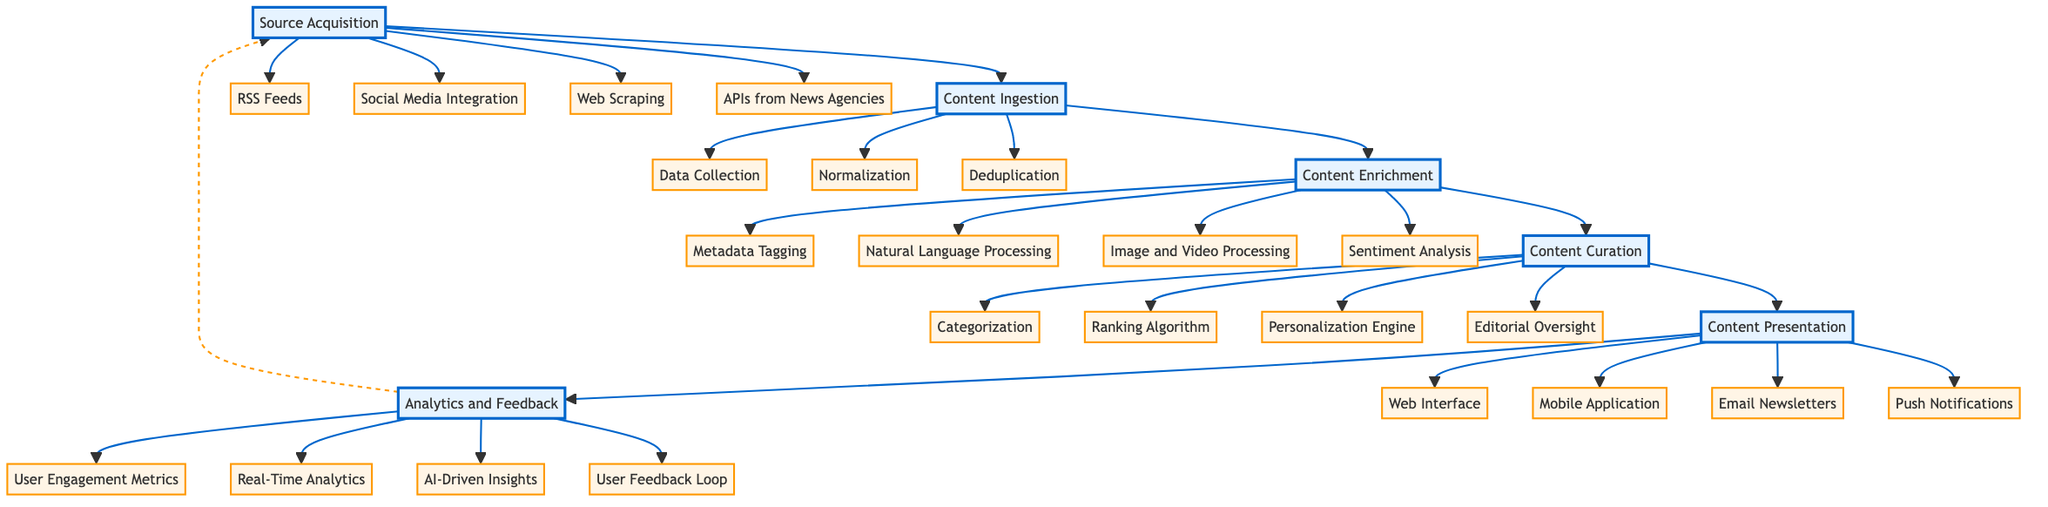What is the first stage in the content curation pipeline? The first stage in the content curation pipeline is indicated by the topmost node in the diagram, which is "Source Acquisition." This is the starting point where various sources of content are gathered.
Answer: Source Acquisition How many sub-elements are under "Content Enrichment"? To find the number of sub-elements under "Content Enrichment," we count the items listed directly below this node in the diagram, which includes four sub-elements.
Answer: Four What process follows "Content Ingestion"? "Content Ingestion" is directly connected to "Content Enrichment" in the diagram as the next stage of the pipeline, indicating the step that comes after ingestion.
Answer: Content Enrichment Which sub-element is responsible for understanding users' preferences? The "Personalization Engine," located under the "Content Curation" node, is key for tailoring content to individual preferences or interests, as stated in the diagram.
Answer: Personalization Engine What connects "Analytics and Feedback" back to "Source Acquisition"? In the diagram, the "Analytics and Feedback" stage has a dashed arrow pointing back to "Source Acquisition," indicating a feedback loop that signifies how insights gained can influence future content sourcing.
Answer: Feedback Loop List all the platforms utilized for "Content Presentation." By examining the sub-elements of "Content Presentation," we can identify four different platforms represented in the diagram: Web Interface, Mobile Application, Email Newsletters, and Push Notifications.
Answer: Web Interface, Mobile Application, Email Newsletters, Push Notifications What is the main purpose of "Content Curation"? Based on the indicated sub-elements such as Categorization, Ranking Algorithm, Personalization Engine, and Editorial Oversight, "Content Curation" serves to organize and prioritize content to deliver the most relevant news to users.
Answer: Organizing and prioritizing content How many methods are used for "Source Acquisition"? The count of sub-elements listed under "Source Acquisition" reveals there are four distinct methods for acquiring content: RSS Feeds, Social Media Integration, Web Scraping, and APIs from News Agencies.
Answer: Four What enhances the gathered content in the pipeline? "Content Enrichment" is the stage specifically aimed at enhancing gathered content; it involves processes such as Metadata Tagging and Sentiment Analysis to improve the quality and depth of the content.
Answer: Content Enrichment 